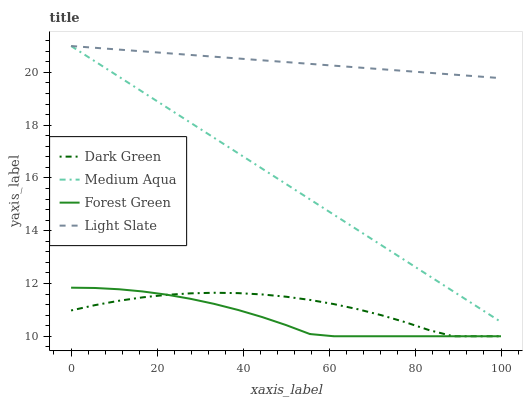Does Forest Green have the minimum area under the curve?
Answer yes or no. Yes. Does Light Slate have the maximum area under the curve?
Answer yes or no. Yes. Does Medium Aqua have the minimum area under the curve?
Answer yes or no. No. Does Medium Aqua have the maximum area under the curve?
Answer yes or no. No. Is Light Slate the smoothest?
Answer yes or no. Yes. Is Dark Green the roughest?
Answer yes or no. Yes. Is Forest Green the smoothest?
Answer yes or no. No. Is Forest Green the roughest?
Answer yes or no. No. Does Forest Green have the lowest value?
Answer yes or no. Yes. Does Medium Aqua have the lowest value?
Answer yes or no. No. Does Medium Aqua have the highest value?
Answer yes or no. Yes. Does Forest Green have the highest value?
Answer yes or no. No. Is Forest Green less than Light Slate?
Answer yes or no. Yes. Is Light Slate greater than Forest Green?
Answer yes or no. Yes. Does Light Slate intersect Medium Aqua?
Answer yes or no. Yes. Is Light Slate less than Medium Aqua?
Answer yes or no. No. Is Light Slate greater than Medium Aqua?
Answer yes or no. No. Does Forest Green intersect Light Slate?
Answer yes or no. No. 